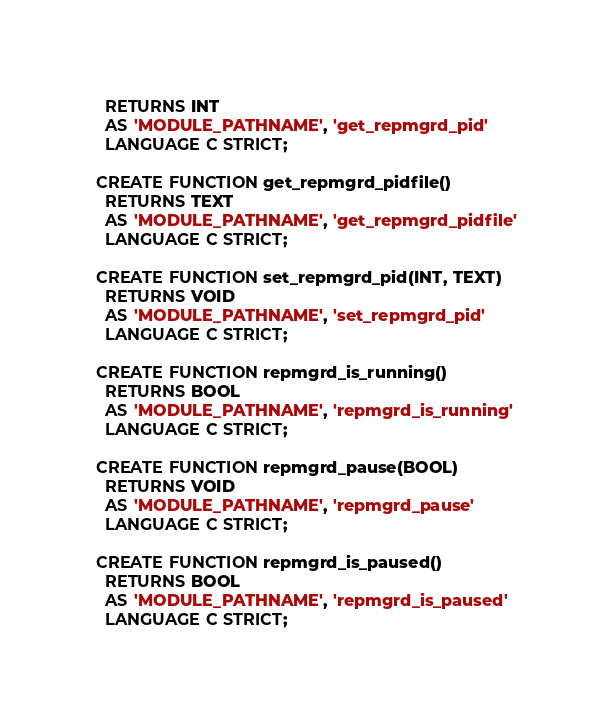Convert code to text. <code><loc_0><loc_0><loc_500><loc_500><_SQL_>  RETURNS INT
  AS 'MODULE_PATHNAME', 'get_repmgrd_pid'
  LANGUAGE C STRICT;

CREATE FUNCTION get_repmgrd_pidfile()
  RETURNS TEXT
  AS 'MODULE_PATHNAME', 'get_repmgrd_pidfile'
  LANGUAGE C STRICT;

CREATE FUNCTION set_repmgrd_pid(INT, TEXT)
  RETURNS VOID
  AS 'MODULE_PATHNAME', 'set_repmgrd_pid'
  LANGUAGE C STRICT;

CREATE FUNCTION repmgrd_is_running()
  RETURNS BOOL
  AS 'MODULE_PATHNAME', 'repmgrd_is_running'
  LANGUAGE C STRICT;

CREATE FUNCTION repmgrd_pause(BOOL)
  RETURNS VOID
  AS 'MODULE_PATHNAME', 'repmgrd_pause'
  LANGUAGE C STRICT;

CREATE FUNCTION repmgrd_is_paused()
  RETURNS BOOL
  AS 'MODULE_PATHNAME', 'repmgrd_is_paused'
  LANGUAGE C STRICT;
</code> 